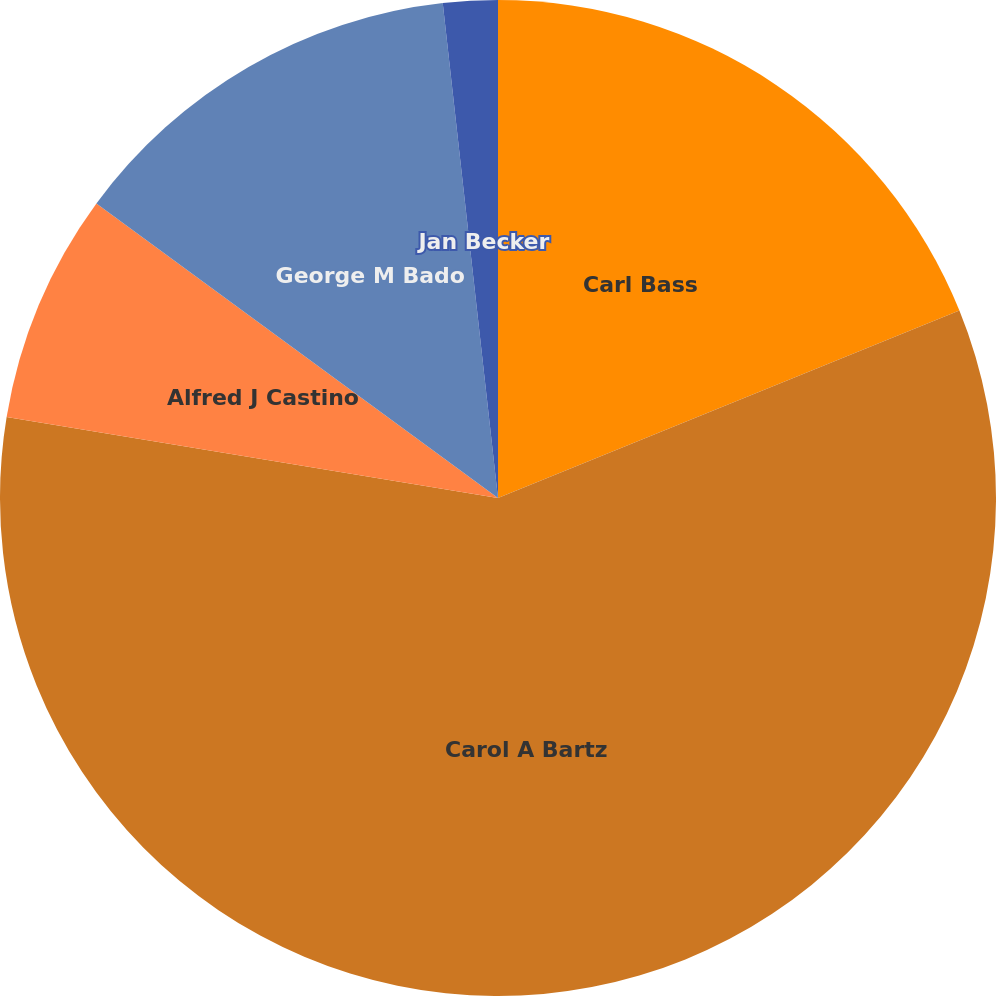Convert chart to OTSL. <chart><loc_0><loc_0><loc_500><loc_500><pie_chart><fcel>Carl Bass<fcel>Carol A Bartz<fcel>Alfred J Castino<fcel>George M Bado<fcel>Jan Becker<nl><fcel>18.86%<fcel>58.74%<fcel>7.47%<fcel>13.16%<fcel>1.77%<nl></chart> 